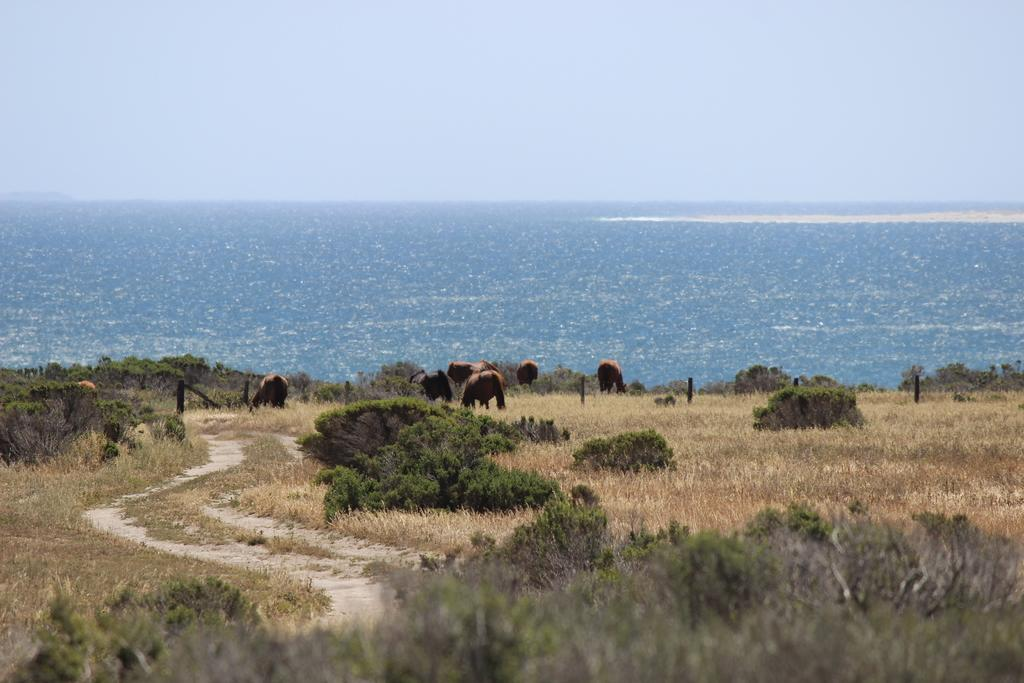What type of vegetation is present in the image? There is grass in the image. What other living beings can be seen in the image? There are animals in the image. What can be seen in the distance in the image? There is water visible in the background of the image. What is visible above the grass and animals in the image? The sky is visible in the background of the image. How many quarters can be seen on the island in the image? There is no island or quarters present in the image. 